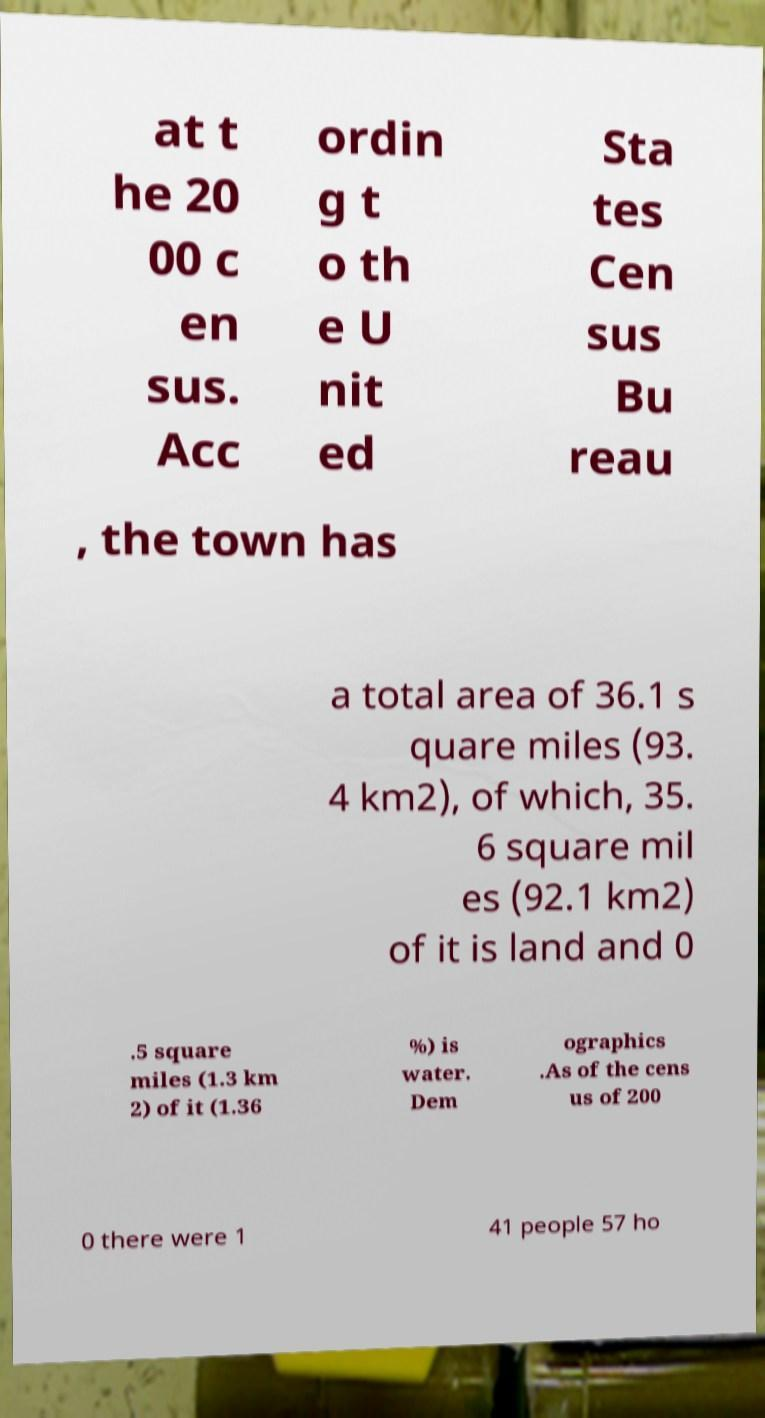Please identify and transcribe the text found in this image. at t he 20 00 c en sus. Acc ordin g t o th e U nit ed Sta tes Cen sus Bu reau , the town has a total area of 36.1 s quare miles (93. 4 km2), of which, 35. 6 square mil es (92.1 km2) of it is land and 0 .5 square miles (1.3 km 2) of it (1.36 %) is water. Dem ographics .As of the cens us of 200 0 there were 1 41 people 57 ho 